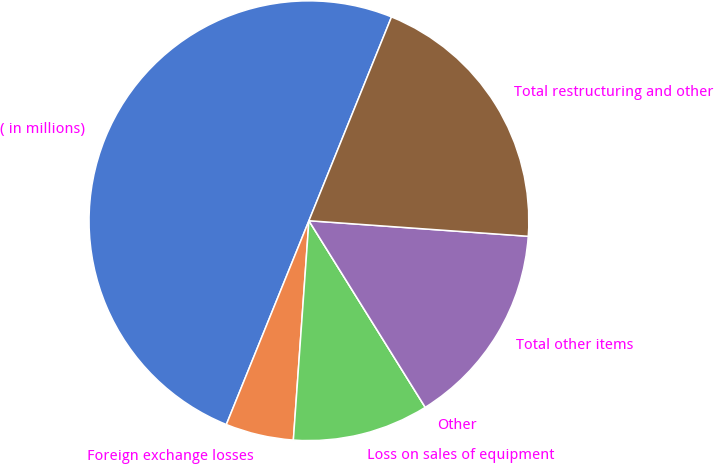Convert chart. <chart><loc_0><loc_0><loc_500><loc_500><pie_chart><fcel>( in millions)<fcel>Foreign exchange losses<fcel>Loss on sales of equipment<fcel>Other<fcel>Total other items<fcel>Total restructuring and other<nl><fcel>50.0%<fcel>5.0%<fcel>10.0%<fcel>0.0%<fcel>15.0%<fcel>20.0%<nl></chart> 